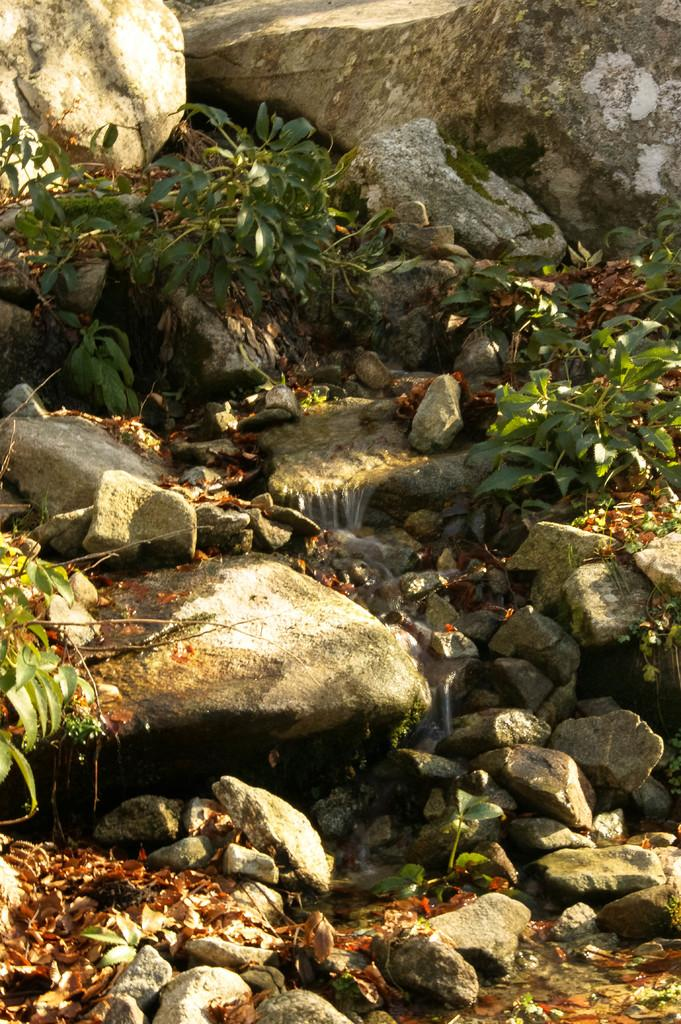What type of living organisms can be seen in the image? Plants can be seen in the image. What other objects are present in the image? There are stones and water visible in the image. What might be the result of the dry leaves in the image? The dry leaves in the image might be a result of the plants shedding their leaves or the leaves drying out due to environmental conditions. What is the owner's belief about the plants in the image? There is no information about an owner or their beliefs in the image, so it cannot be determined. 